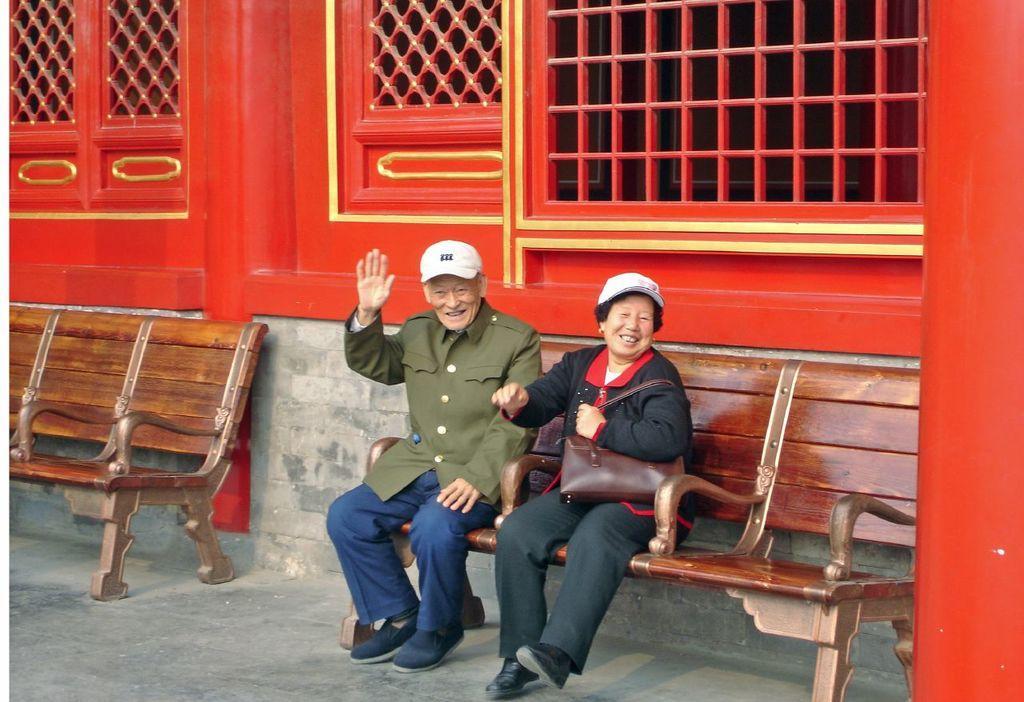How would you summarize this image in a sentence or two? In the picture there are two long chairs on one of them a man and a woman are sitting both of them are smiling in the background there is a red color window and a cement color wall. 